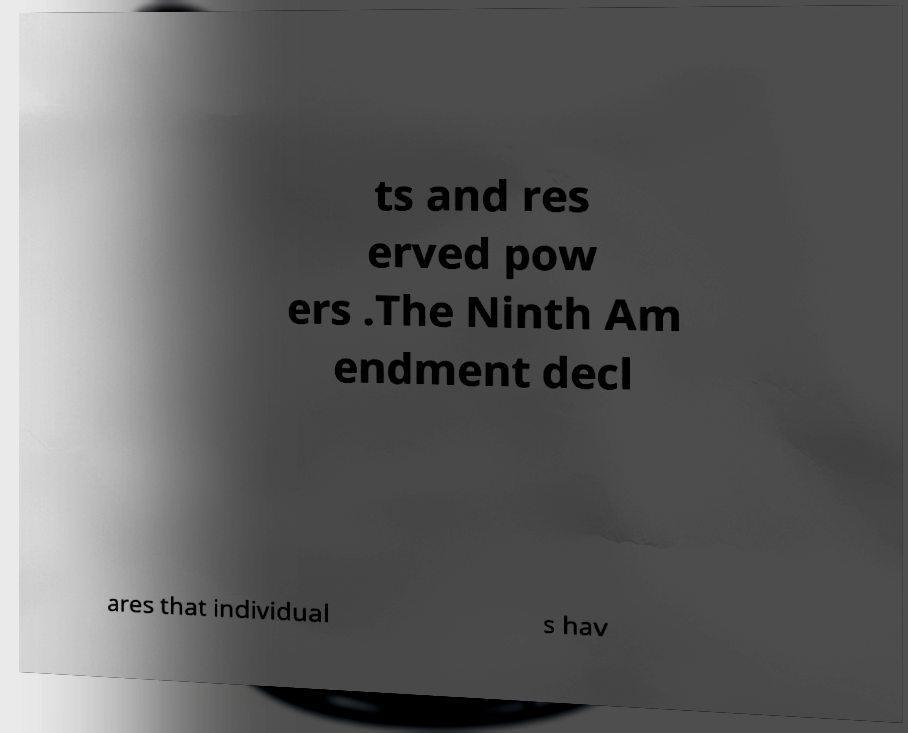Could you assist in decoding the text presented in this image and type it out clearly? ts and res erved pow ers .The Ninth Am endment decl ares that individual s hav 